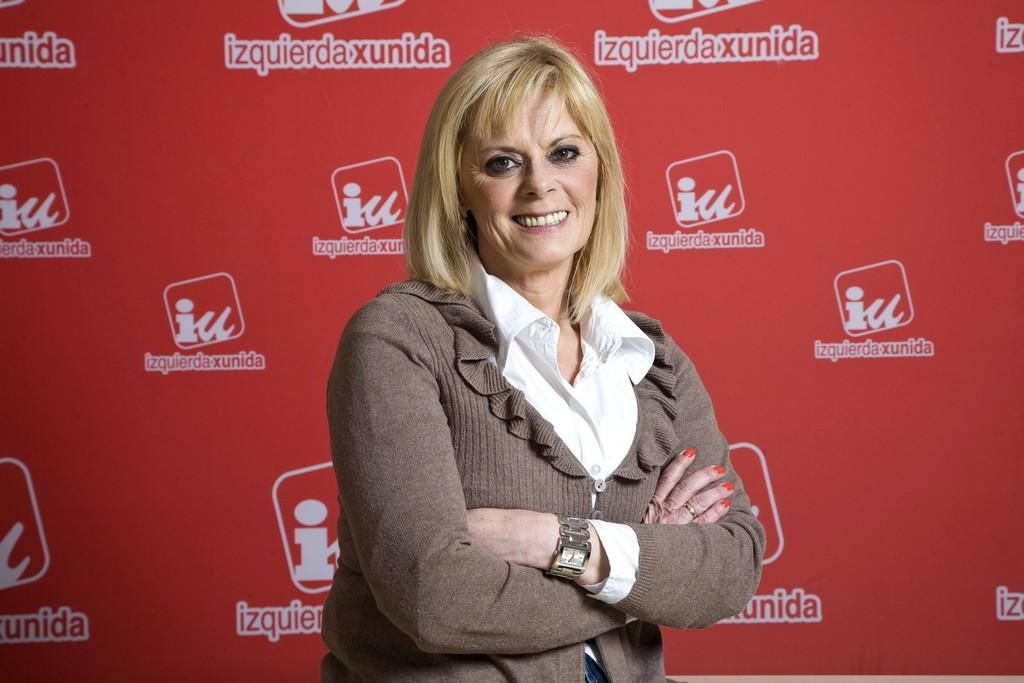Who is present in the image? There is a woman in the image. What is the woman's facial expression? The woman has a smiling face. What can be seen in the background of the image? There is a banner in the background of the image. What is written on the banner? The banner has text on it. What color is the bath in the image? There is no bath present in the image. Can you tell me what request the woman is making in the image? The image does not show the woman making any request, as it only shows her smiling face and the banner in the background. 